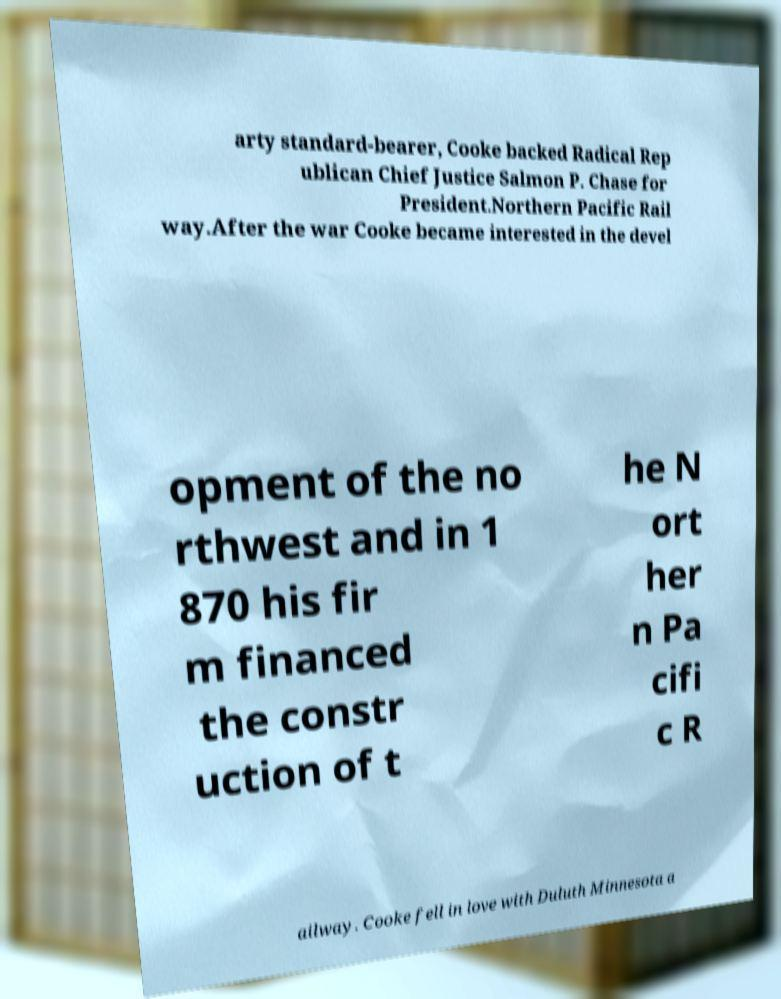For documentation purposes, I need the text within this image transcribed. Could you provide that? arty standard-bearer, Cooke backed Radical Rep ublican Chief Justice Salmon P. Chase for President.Northern Pacific Rail way.After the war Cooke became interested in the devel opment of the no rthwest and in 1 870 his fir m financed the constr uction of t he N ort her n Pa cifi c R ailway. Cooke fell in love with Duluth Minnesota a 